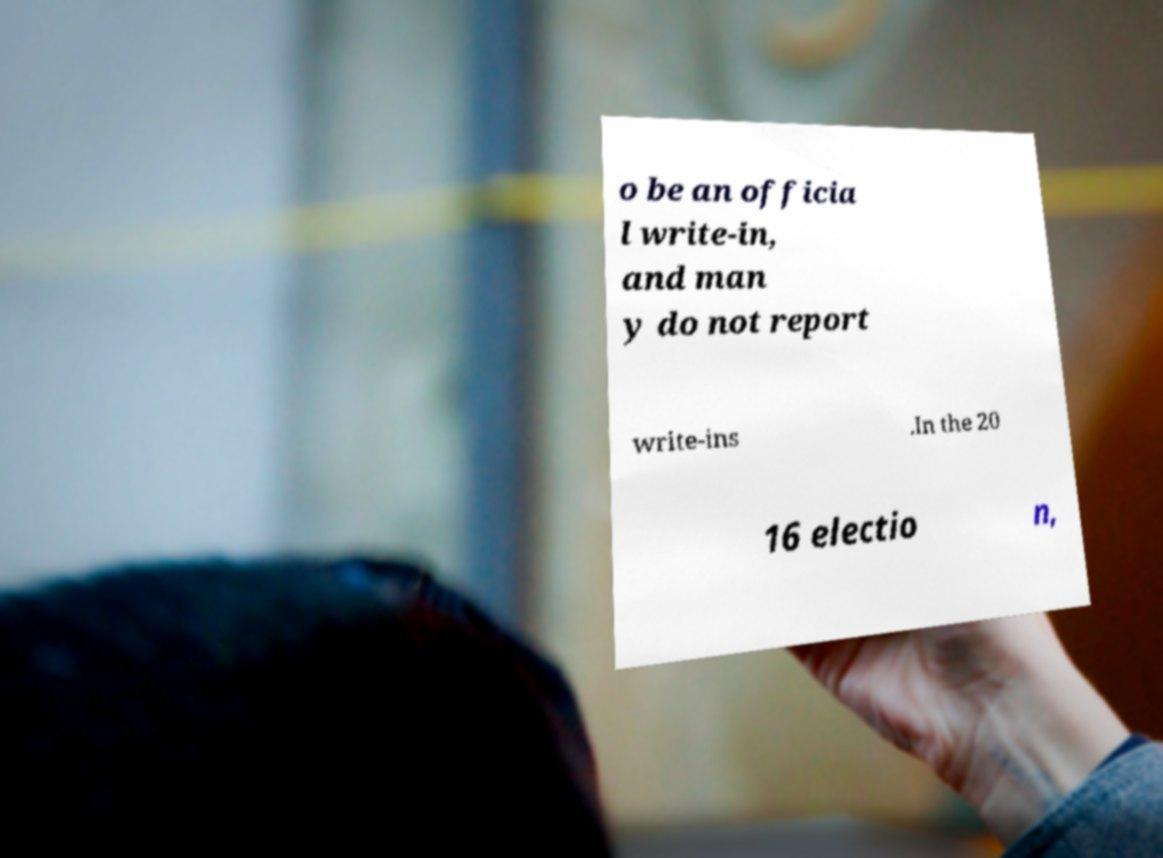Can you read and provide the text displayed in the image?This photo seems to have some interesting text. Can you extract and type it out for me? o be an officia l write-in, and man y do not report write-ins .In the 20 16 electio n, 